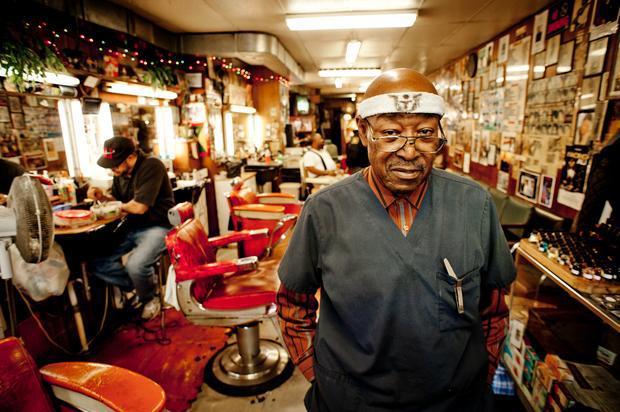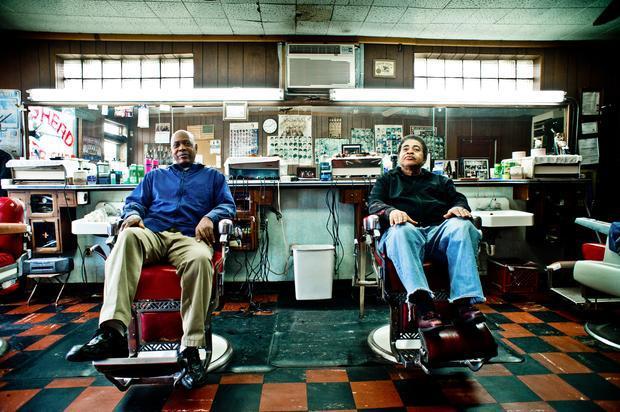The first image is the image on the left, the second image is the image on the right. For the images shown, is this caption "In at least one image there is a single man in a suit and tie sitting in a barber chair." true? Answer yes or no. No. The first image is the image on the left, the second image is the image on the right. Analyze the images presented: Is the assertion "The left image shows an older black man in suit, tie and eyeglasses, sitting on a white barber chair." valid? Answer yes or no. No. 